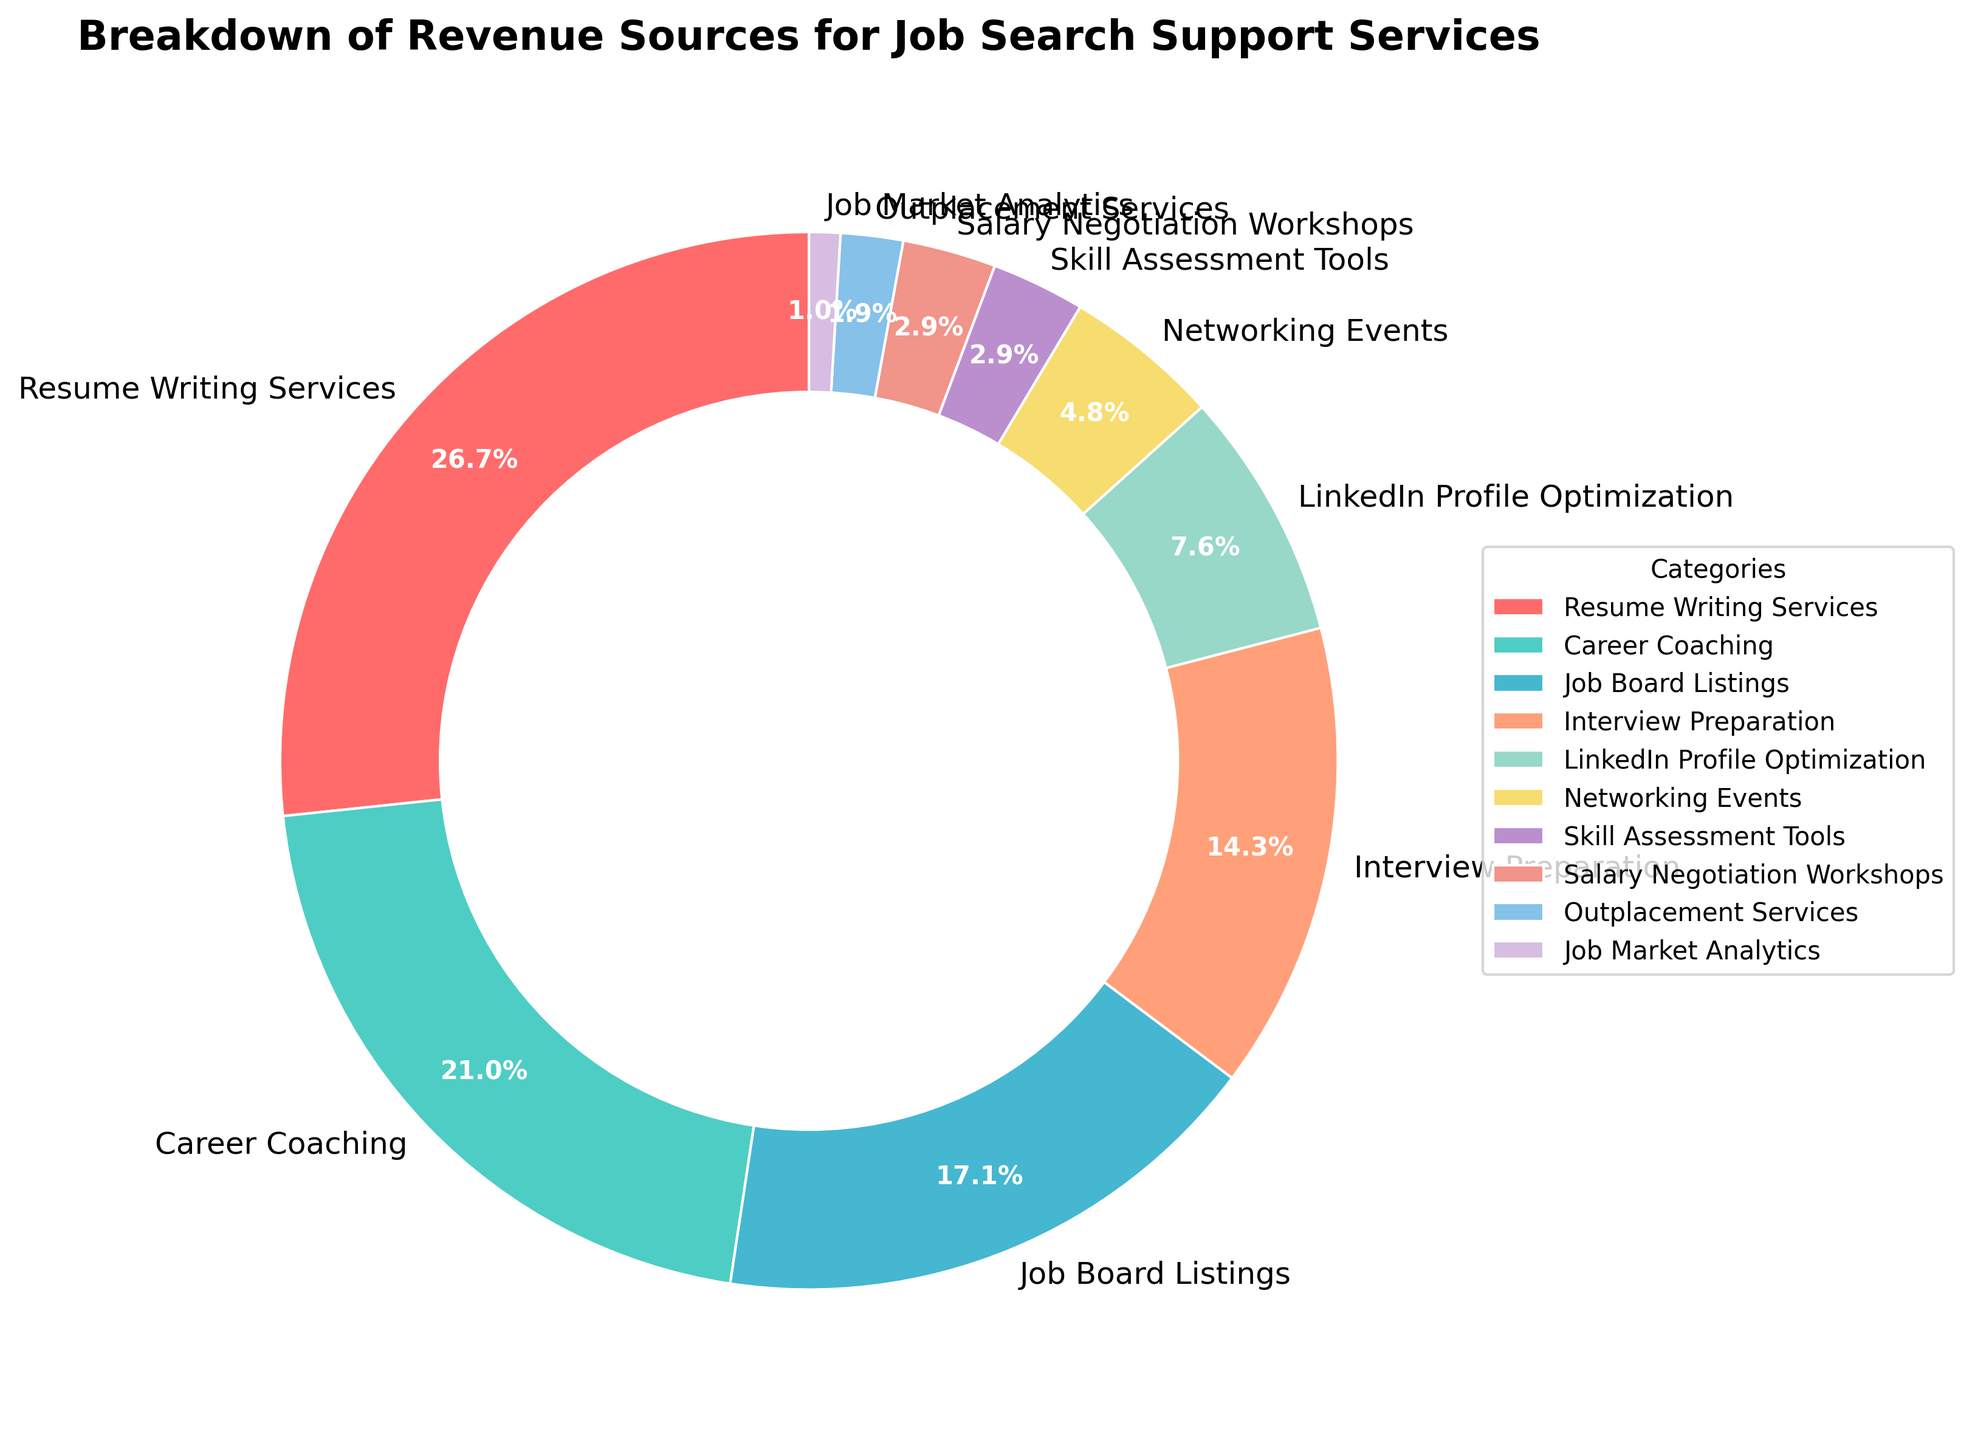What is the largest source of revenue for job search support services? The largest source of revenue is the category with the highest percentage on the pie chart. Resume Writing Services has the highest percentage at 28%.
Answer: Resume Writing Services What percentage of revenue comes from Interview Preparation and LinkedIn Profile Optimization combined? To find the combined percentage, sum the percentages of both categories. Interview Preparation has 15% and LinkedIn Profile Optimization has 8%, so 15% + 8% = 23%.
Answer: 23% Which categories account for less than 5% of the total revenue? Categories with less than 5% can be identified on the pie chart. These are Networking Events (5%), Skill Assessment Tools (3%), Salary Negotiation Workshops (3%), Outplacement Services (2%), and Job Market Analytics (1%).
Answer: Networking Events, Skill Assessment Tools, Salary Negotiation Workshops, Outplacement Services, Job Market Analytics Of Resume Writing Services and Career Coaching, which category contributes more to the revenue? By how much? Compare the percentages of the two categories. Resume Writing Services has 28% and Career Coaching has 22%. The difference is 28% - 22% = 6%.
Answer: Resume Writing Services, by 6% What proportion of the pie chart is represented by categories related to resume and LinkedIn services? Sum the percentages of Resume Writing Services and LinkedIn Profile Optimization. Resume Writing Services has 28% and LinkedIn Profile Optimization has 8%, so 28% + 8% = 36%.
Answer: 36% Compare the revenue contribution of Networking Events and Skill Assessment Tools. Which is higher and by how much? Compare their percentages. Networking Events has 5% and Skill Assessment Tools has 3%. The difference is 5% - 3% = 2%.
Answer: Networking Events, by 2% What are the second and third largest sources of revenue? Identify the categories with the second and third highest percentages after Resume Writing Services. Career Coaching is second with 22%, and Job Board Listings is third with 18%.
Answer: Career Coaching, Job Board Listings If the revenue from Interview Preparation increases by 5%, what will its new percentage be? Add 5% to the current percentage of Interview Preparation. The current percentage is 15%, so the new percentage will be 15% + 5% = 20%.
Answer: 20% Which category contributes the least to the revenue? Identify the category with the smallest percentage. Job Market Analytics has the smallest percentage at 1%.
Answer: Job Market Analytics 